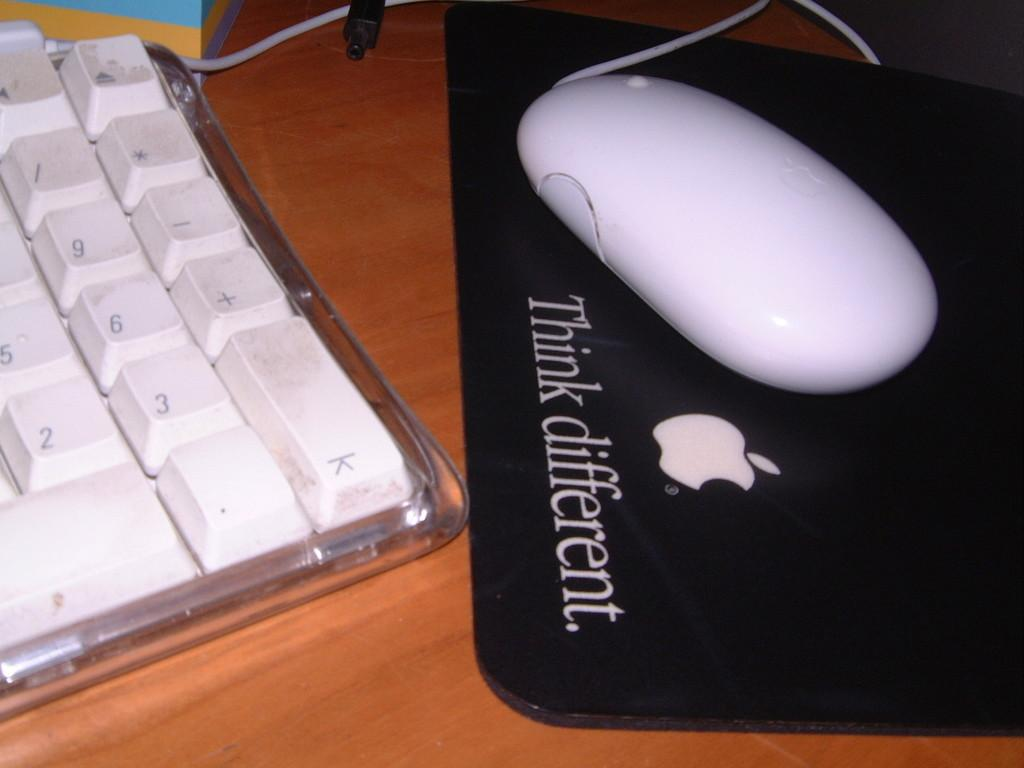<image>
Provide a brief description of the given image. A keyboard sitting next to a Black mousepad with the words Think different printed on it with a white mouse laying on top. 